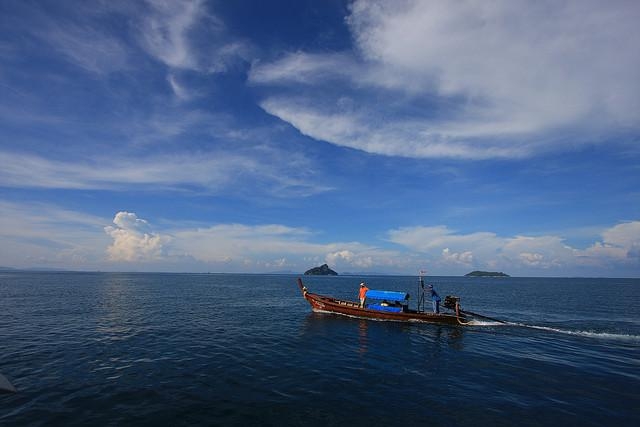What propels this craft forward? motor 